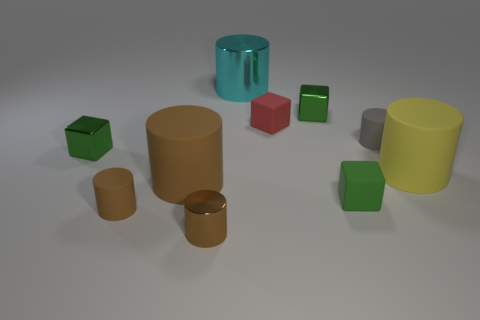What shape is the green object that is on the left side of the green object that is behind the tiny green block that is to the left of the large metal object?
Provide a succinct answer. Cube. Do the metallic cylinder in front of the cyan cylinder and the small matte cylinder that is left of the red rubber thing have the same color?
Offer a very short reply. Yes. How many small metal cylinders are there?
Offer a very short reply. 1. Are there any cubes to the right of the big cyan metal thing?
Provide a short and direct response. Yes. Is the large yellow cylinder that is behind the tiny green matte block made of the same material as the gray cylinder in front of the tiny red rubber block?
Offer a terse response. Yes. Are there fewer yellow cylinders that are in front of the tiny brown shiny object than small cylinders?
Provide a short and direct response. Yes. There is a small rubber cylinder on the right side of the small red rubber thing; what is its color?
Provide a succinct answer. Gray. What is the material of the tiny green block left of the small shiny object that is in front of the yellow thing?
Offer a terse response. Metal. Are there any other cylinders of the same size as the yellow cylinder?
Offer a terse response. Yes. What number of objects are tiny blocks that are to the right of the small brown rubber thing or tiny cubes that are in front of the large yellow object?
Ensure brevity in your answer.  3. 